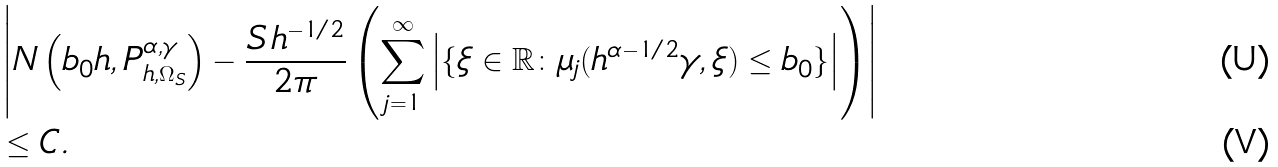Convert formula to latex. <formula><loc_0><loc_0><loc_500><loc_500>& \left | N \left ( b _ { 0 } h , P _ { h , \Omega _ { S } } ^ { \alpha , \gamma } \right ) - \frac { S \, h ^ { - 1 / 2 } } { 2 \pi } \left ( \sum _ { j = 1 } ^ { \infty } \left | \{ \xi \in \mathbb { R } \colon \mu _ { j } ( h ^ { \alpha - 1 / 2 } \gamma , \xi ) \leq b _ { 0 } \} \right | \right ) \right | \\ & \leq C .</formula> 